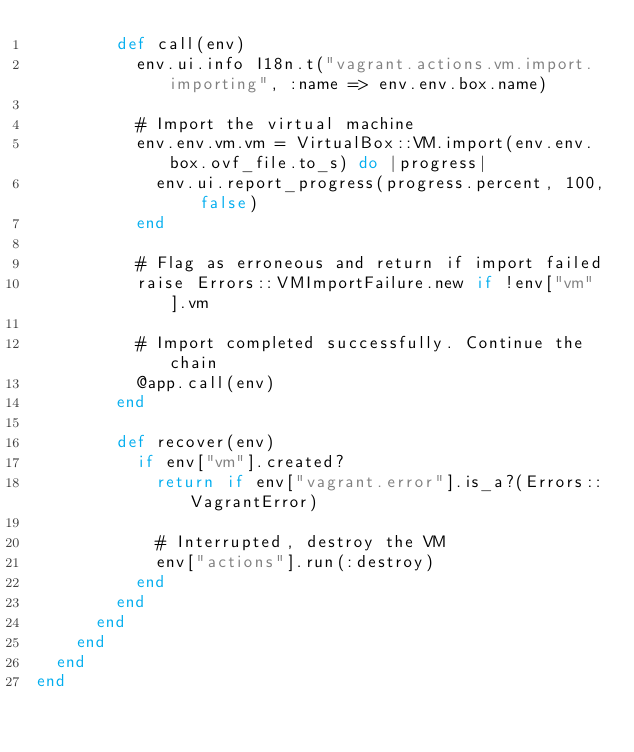Convert code to text. <code><loc_0><loc_0><loc_500><loc_500><_Ruby_>        def call(env)
          env.ui.info I18n.t("vagrant.actions.vm.import.importing", :name => env.env.box.name)

          # Import the virtual machine
          env.env.vm.vm = VirtualBox::VM.import(env.env.box.ovf_file.to_s) do |progress|
            env.ui.report_progress(progress.percent, 100, false)
          end

          # Flag as erroneous and return if import failed
          raise Errors::VMImportFailure.new if !env["vm"].vm

          # Import completed successfully. Continue the chain
          @app.call(env)
        end

        def recover(env)
          if env["vm"].created?
            return if env["vagrant.error"].is_a?(Errors::VagrantError)

            # Interrupted, destroy the VM
            env["actions"].run(:destroy)
          end
        end
      end
    end
  end
end
</code> 